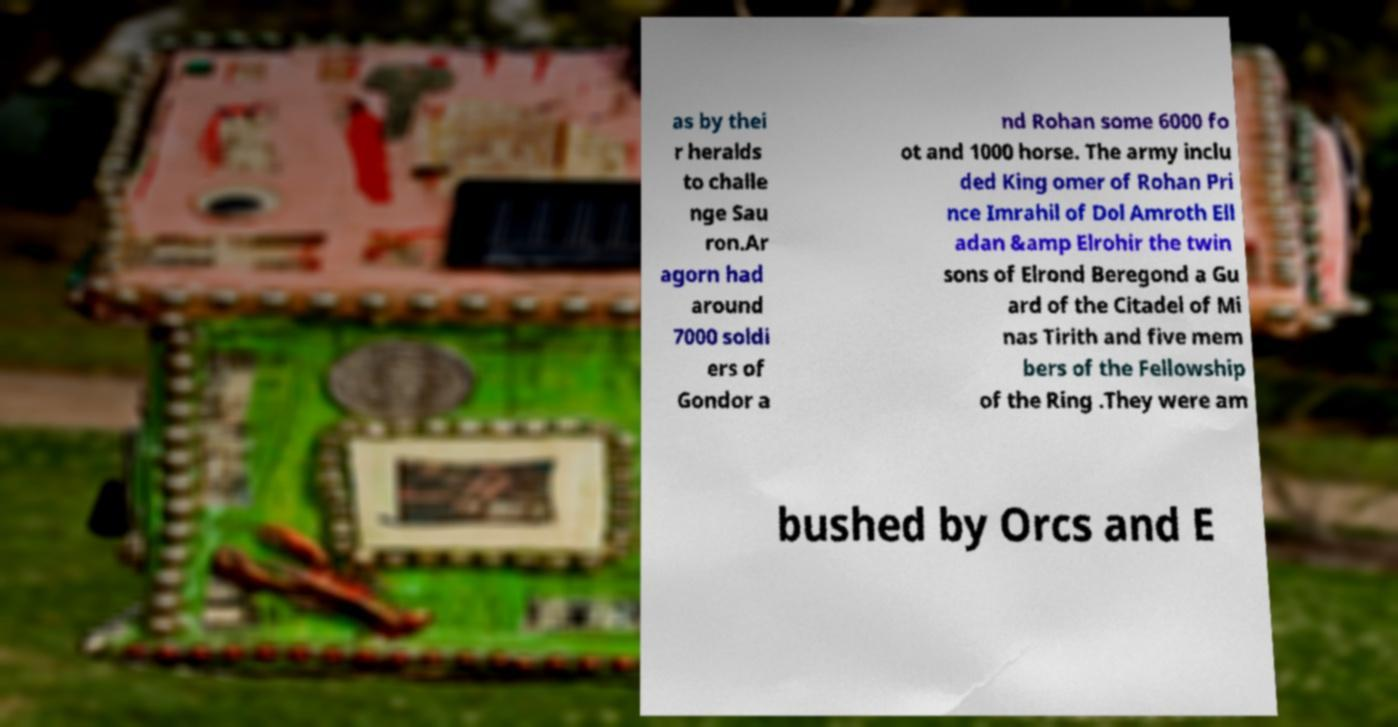There's text embedded in this image that I need extracted. Can you transcribe it verbatim? as by thei r heralds to challe nge Sau ron.Ar agorn had around 7000 soldi ers of Gondor a nd Rohan some 6000 fo ot and 1000 horse. The army inclu ded King omer of Rohan Pri nce Imrahil of Dol Amroth Ell adan &amp Elrohir the twin sons of Elrond Beregond a Gu ard of the Citadel of Mi nas Tirith and five mem bers of the Fellowship of the Ring .They were am bushed by Orcs and E 